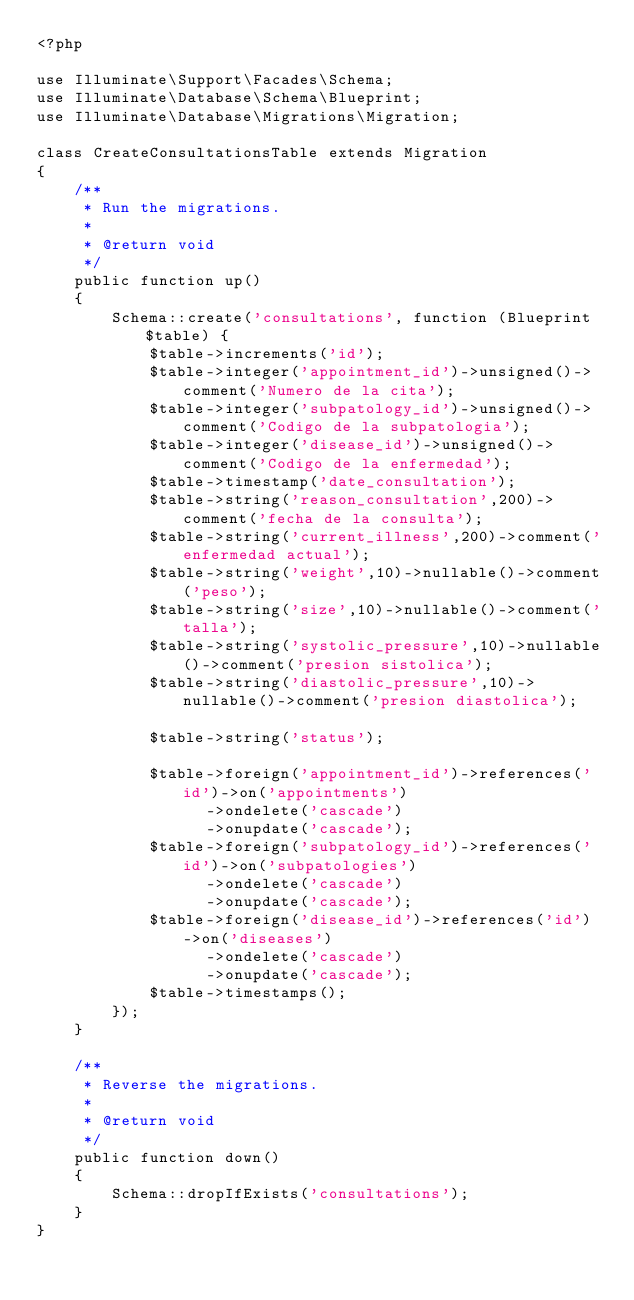Convert code to text. <code><loc_0><loc_0><loc_500><loc_500><_PHP_><?php

use Illuminate\Support\Facades\Schema;
use Illuminate\Database\Schema\Blueprint;
use Illuminate\Database\Migrations\Migration;

class CreateConsultationsTable extends Migration
{
    /**
     * Run the migrations.
     *
     * @return void
     */
    public function up()
    {
        Schema::create('consultations', function (Blueprint $table) {
            $table->increments('id');
            $table->integer('appointment_id')->unsigned()->comment('Numero de la cita');
            $table->integer('subpatology_id')->unsigned()->comment('Codigo de la subpatologia');
            $table->integer('disease_id')->unsigned()->comment('Codigo de la enfermedad');
            $table->timestamp('date_consultation');
            $table->string('reason_consultation',200)->comment('fecha de la consulta');
            $table->string('current_illness',200)->comment('enfermedad actual');
            $table->string('weight',10)->nullable()->comment('peso');
            $table->string('size',10)->nullable()->comment('talla');
            $table->string('systolic_pressure',10)->nullable()->comment('presion sistolica');
            $table->string('diastolic_pressure',10)->nullable()->comment('presion diastolica');
            
            $table->string('status');
            
            $table->foreign('appointment_id')->references('id')->on('appointments')
                  ->ondelete('cascade')
                  ->onupdate('cascade');  
            $table->foreign('subpatology_id')->references('id')->on('subpatologies')
                  ->ondelete('cascade')
                  ->onupdate('cascade'); 
            $table->foreign('disease_id')->references('id')->on('diseases')
                  ->ondelete('cascade')
                  ->onupdate('cascade'); 
            $table->timestamps();
        });
    }

    /**
     * Reverse the migrations.
     *
     * @return void
     */
    public function down()
    {
        Schema::dropIfExists('consultations');
    }
}
</code> 